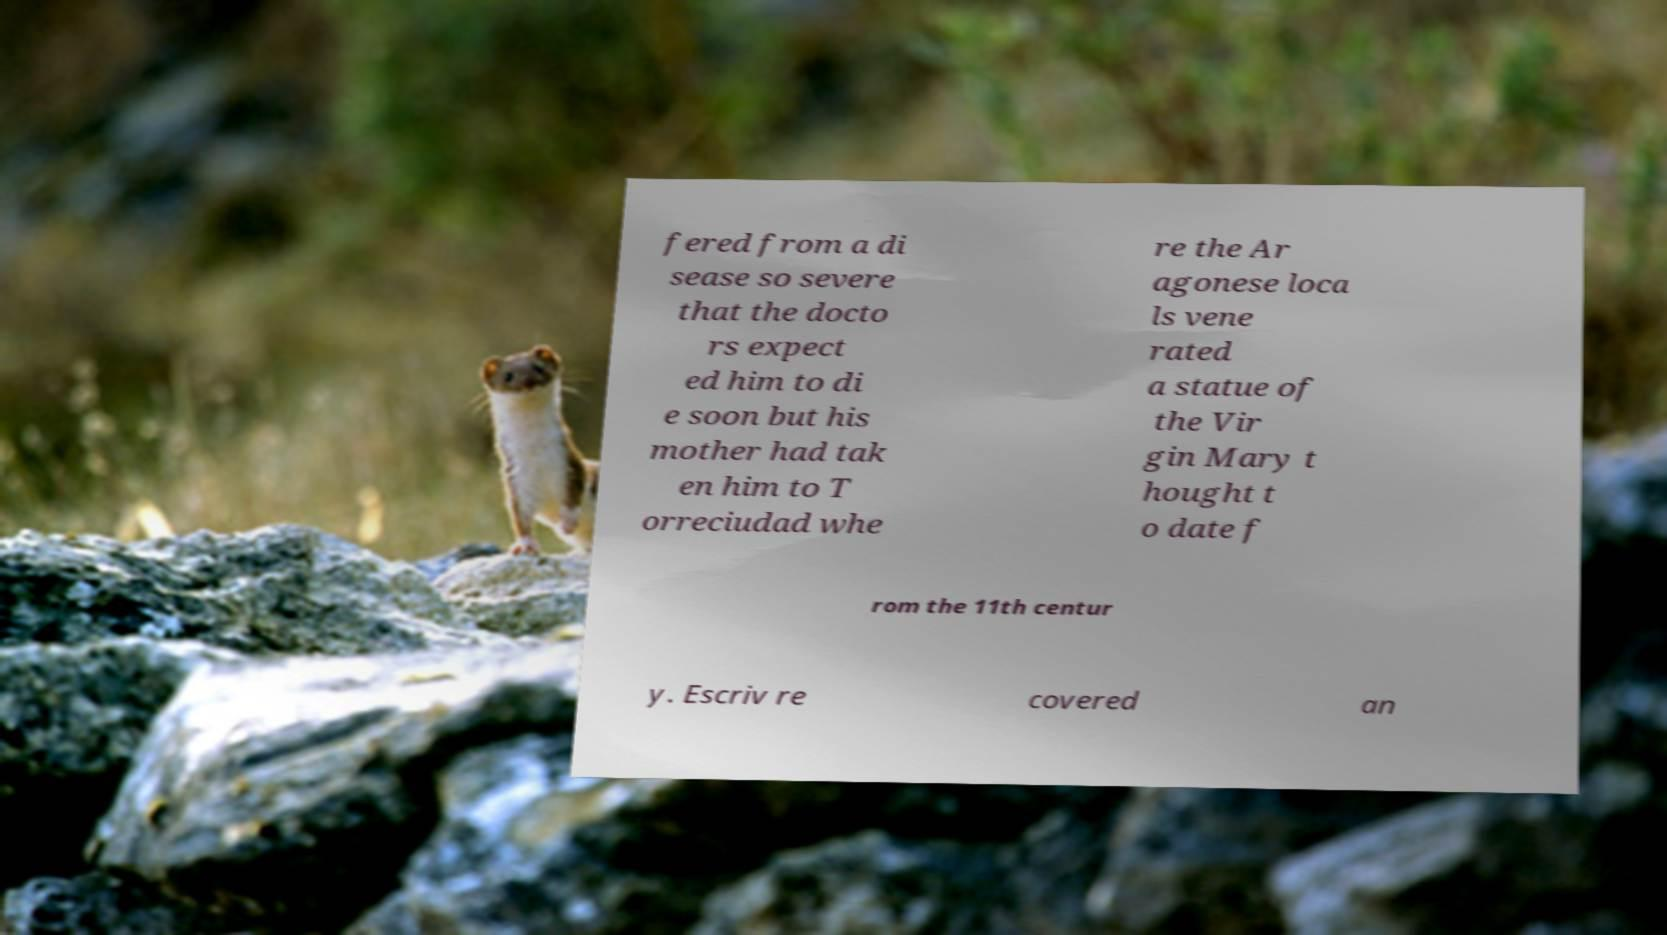Can you read and provide the text displayed in the image?This photo seems to have some interesting text. Can you extract and type it out for me? fered from a di sease so severe that the docto rs expect ed him to di e soon but his mother had tak en him to T orreciudad whe re the Ar agonese loca ls vene rated a statue of the Vir gin Mary t hought t o date f rom the 11th centur y. Escriv re covered an 